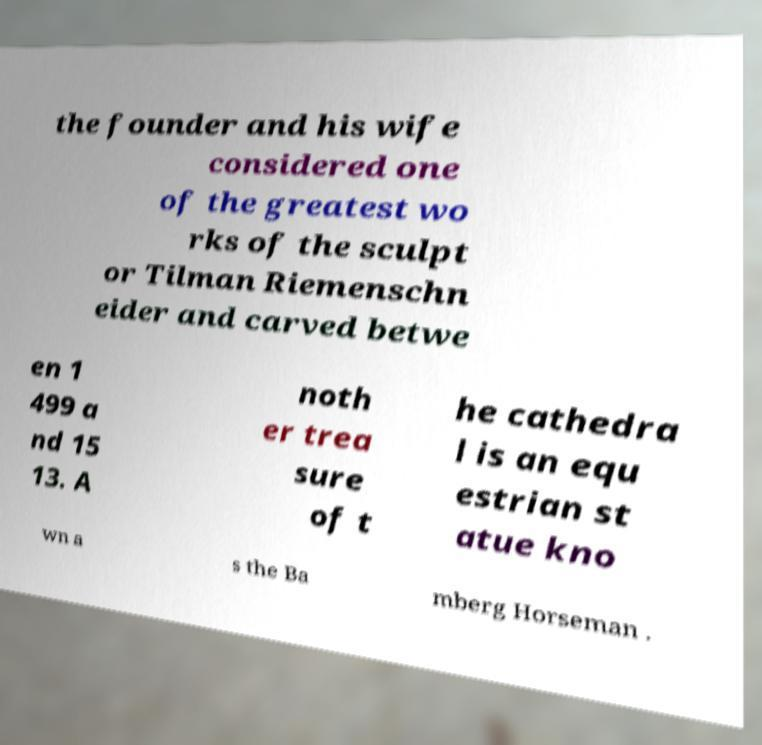There's text embedded in this image that I need extracted. Can you transcribe it verbatim? the founder and his wife considered one of the greatest wo rks of the sculpt or Tilman Riemenschn eider and carved betwe en 1 499 a nd 15 13. A noth er trea sure of t he cathedra l is an equ estrian st atue kno wn a s the Ba mberg Horseman . 